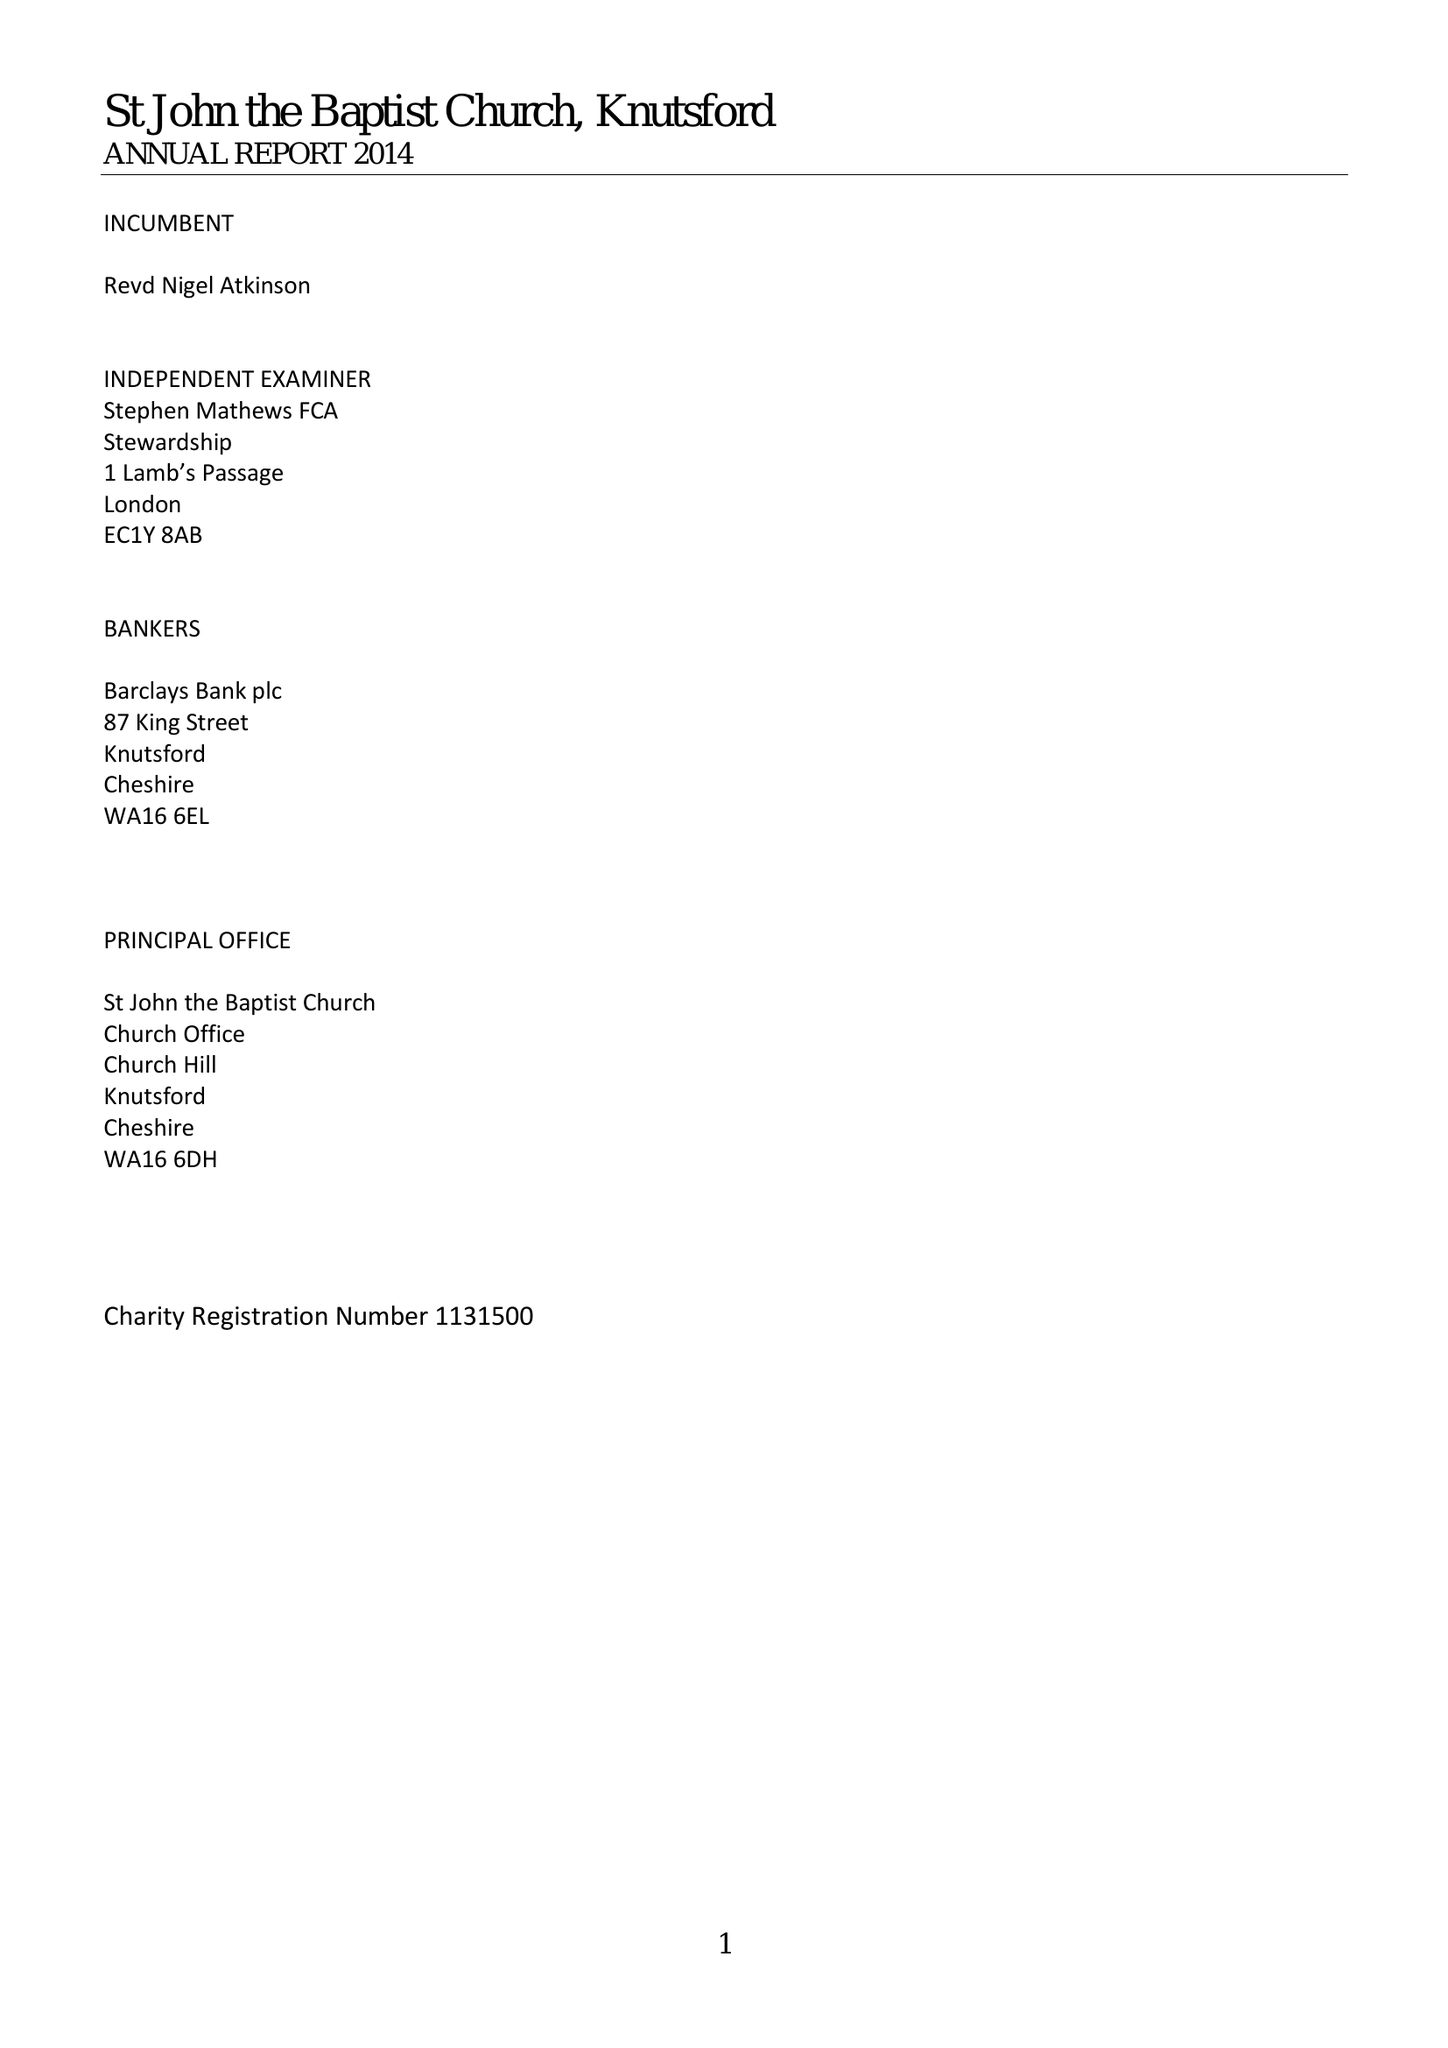What is the value for the charity_name?
Answer the question using a single word or phrase. The Parochial Church Council Of The Ecclesiastical Parish Of St. John The Baptist Knutsford 